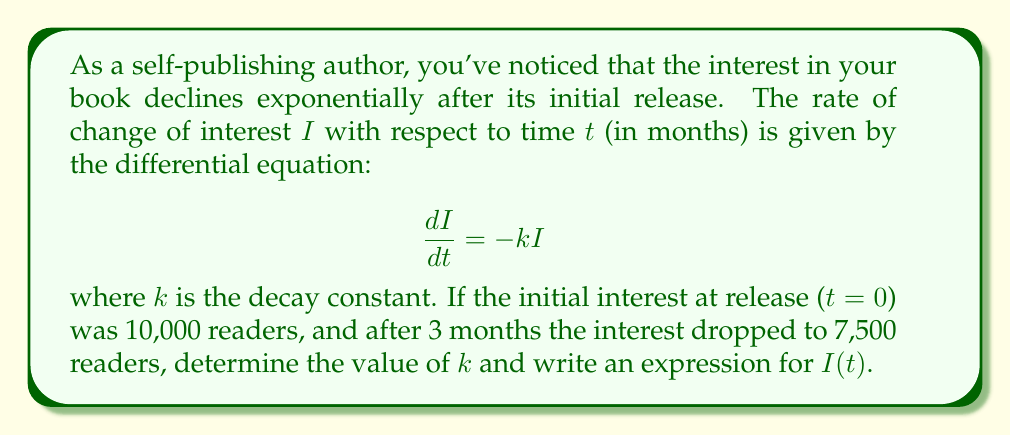Provide a solution to this math problem. To solve this problem, we'll follow these steps:

1) The given differential equation is a first-order linear ODE with constant coefficients. Its general solution is:

   $$I(t) = Ce^{-kt}$$

   where $C$ is a constant determined by the initial condition.

2) We're given the initial condition: $I(0) = 10,000$. Let's use this to find $C$:

   $$I(0) = Ce^{-k(0)} = C = 10,000$$

3) So our specific solution is:

   $$I(t) = 10,000e^{-kt}$$

4) We're also given that after 3 months, $I(3) = 7,500$. Let's use this to find $k$:

   $$7,500 = 10,000e^{-k(3)}$$

5) Dividing both sides by 10,000:

   $$0.75 = e^{-3k}$$

6) Taking the natural log of both sides:

   $$\ln(0.75) = -3k$$

7) Solving for $k$:

   $$k = -\frac{\ln(0.75)}{3} \approx 0.0963$$

8) Now that we have $k$, we can write the final expression for $I(t)$:

   $$I(t) = 10,000e^{-0.0963t}$$

This expression gives the number of interested readers $t$ months after the book's release.
Answer: $k \approx 0.0963$ and $I(t) = 10,000e^{-0.0963t}$ 